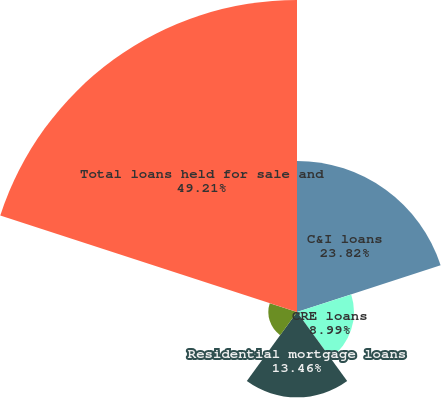Convert chart to OTSL. <chart><loc_0><loc_0><loc_500><loc_500><pie_chart><fcel>C&I loans<fcel>CRE loans<fcel>Residential mortgage loans<fcel>SBL<fcel>Total loans held for sale and<nl><fcel>23.82%<fcel>8.99%<fcel>13.46%<fcel>4.52%<fcel>49.21%<nl></chart> 